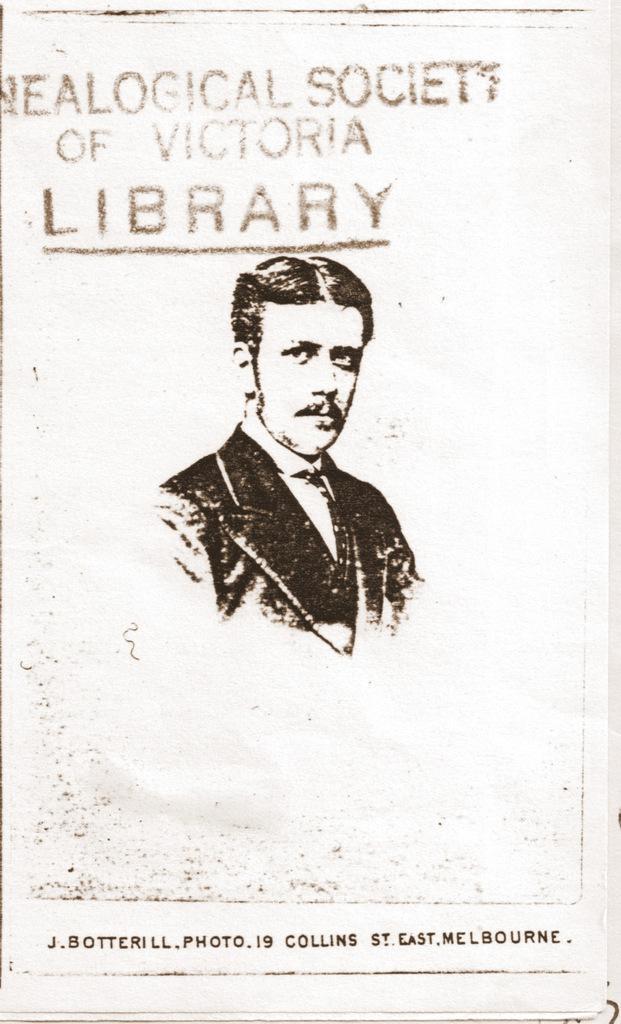Could you give a brief overview of what you see in this image? In the image we can see a paper, in the paper we can see some text and we can see a person drawing. 